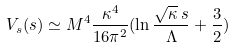<formula> <loc_0><loc_0><loc_500><loc_500>V _ { s } ( s ) \simeq M ^ { 4 } \frac { \kappa ^ { 4 } } { 1 6 \pi ^ { 2 } } ( \ln \frac { \sqrt { \kappa } \, s } { \Lambda } + \frac { 3 } { 2 } )</formula> 